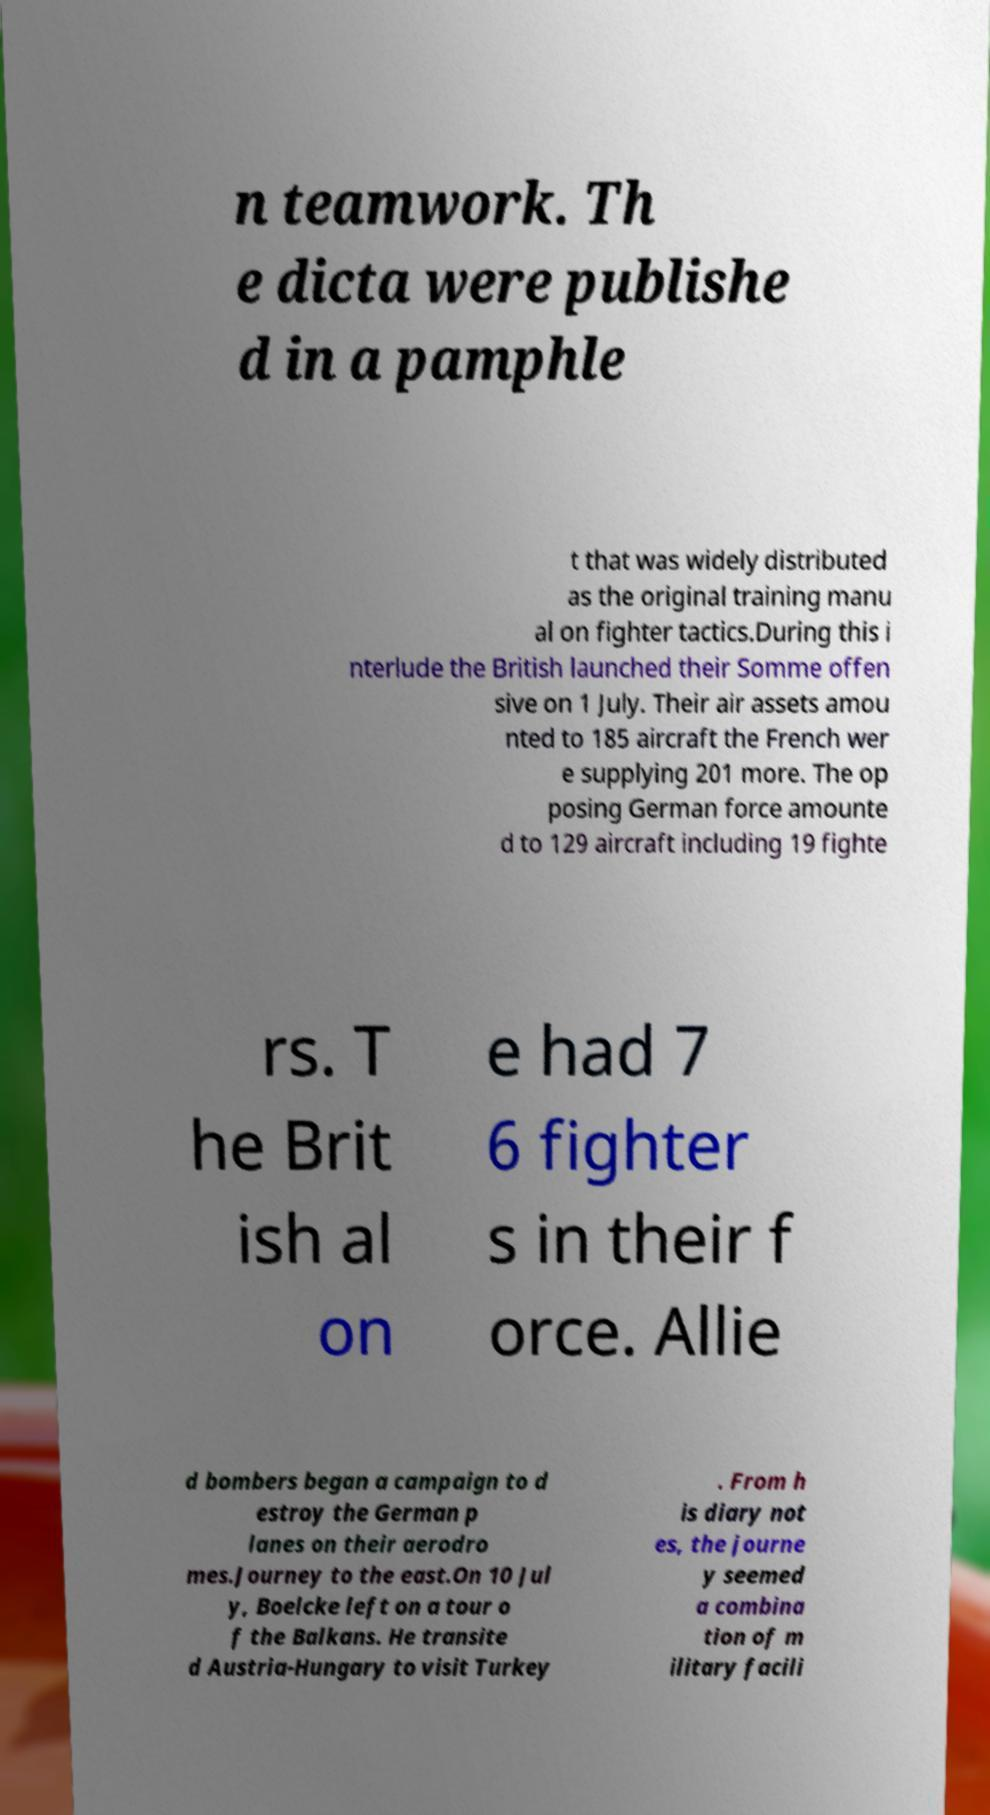Can you read and provide the text displayed in the image?This photo seems to have some interesting text. Can you extract and type it out for me? n teamwork. Th e dicta were publishe d in a pamphle t that was widely distributed as the original training manu al on fighter tactics.During this i nterlude the British launched their Somme offen sive on 1 July. Their air assets amou nted to 185 aircraft the French wer e supplying 201 more. The op posing German force amounte d to 129 aircraft including 19 fighte rs. T he Brit ish al on e had 7 6 fighter s in their f orce. Allie d bombers began a campaign to d estroy the German p lanes on their aerodro mes.Journey to the east.On 10 Jul y, Boelcke left on a tour o f the Balkans. He transite d Austria-Hungary to visit Turkey . From h is diary not es, the journe y seemed a combina tion of m ilitary facili 